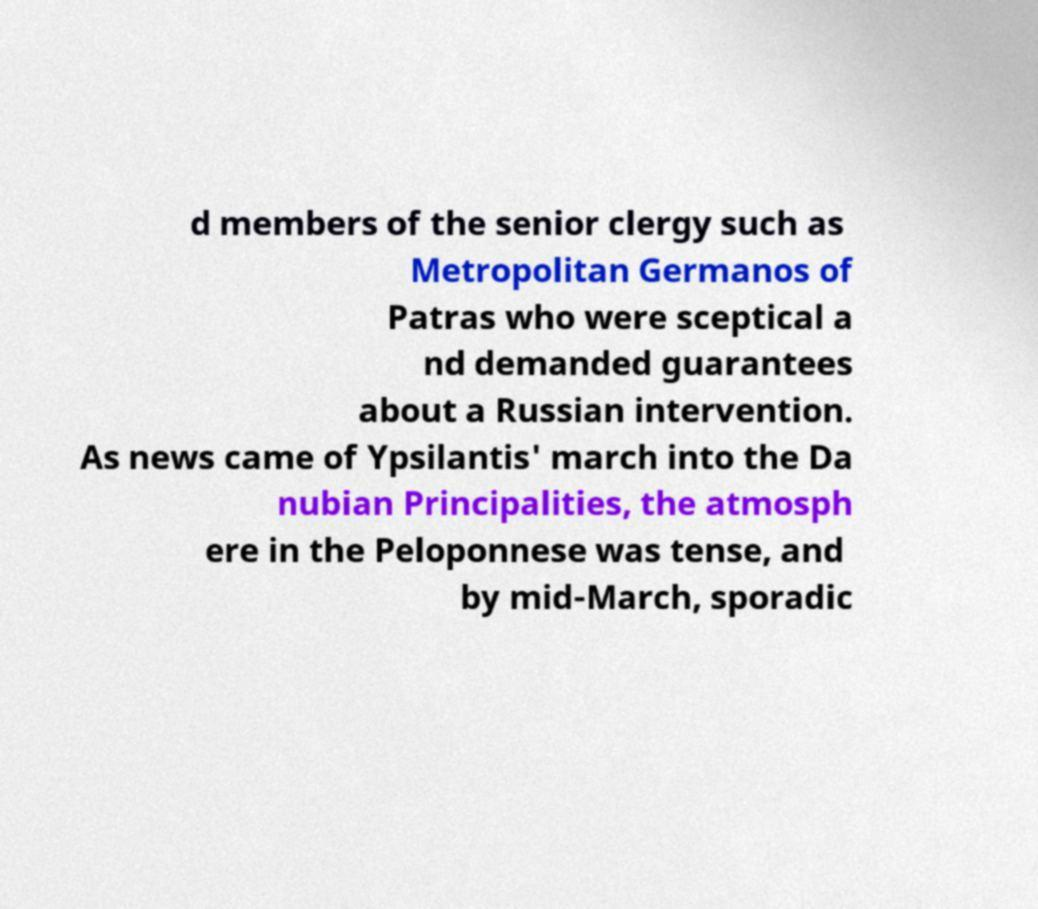I need the written content from this picture converted into text. Can you do that? d members of the senior clergy such as Metropolitan Germanos of Patras who were sceptical a nd demanded guarantees about a Russian intervention. As news came of Ypsilantis' march into the Da nubian Principalities, the atmosph ere in the Peloponnese was tense, and by mid-March, sporadic 